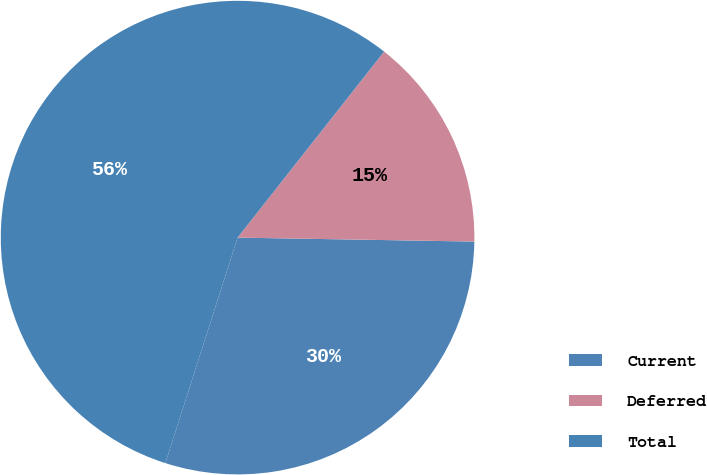Convert chart. <chart><loc_0><loc_0><loc_500><loc_500><pie_chart><fcel>Current<fcel>Deferred<fcel>Total<nl><fcel>29.67%<fcel>14.65%<fcel>55.69%<nl></chart> 